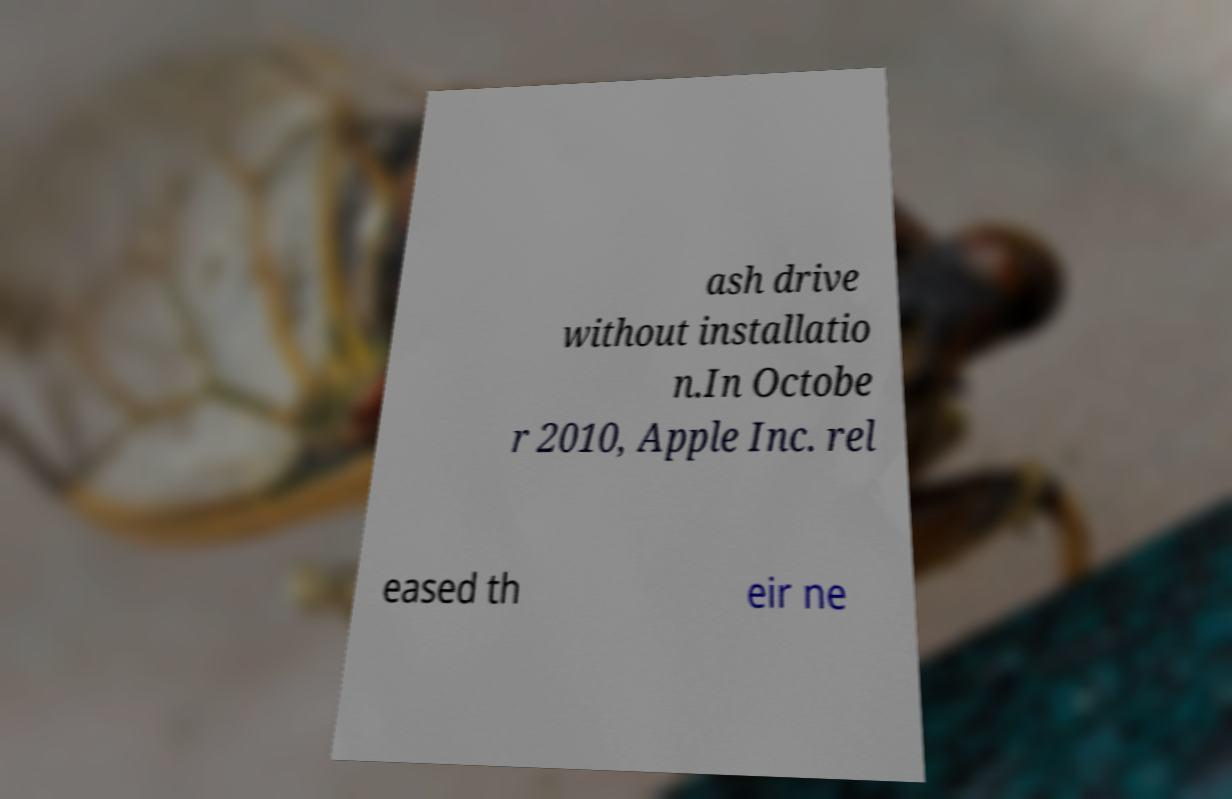Could you assist in decoding the text presented in this image and type it out clearly? ash drive without installatio n.In Octobe r 2010, Apple Inc. rel eased th eir ne 